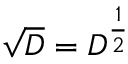<formula> <loc_0><loc_0><loc_500><loc_500>{ \sqrt { D } } = D ^ { \frac { 1 } { 2 } }</formula> 